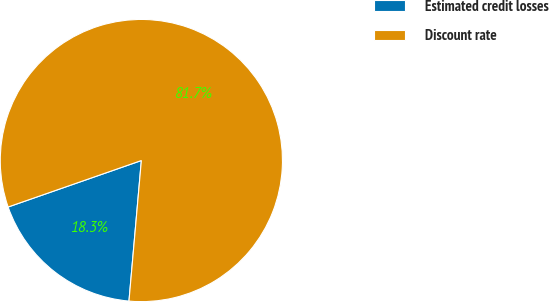Convert chart to OTSL. <chart><loc_0><loc_0><loc_500><loc_500><pie_chart><fcel>Estimated credit losses<fcel>Discount rate<nl><fcel>18.26%<fcel>81.74%<nl></chart> 